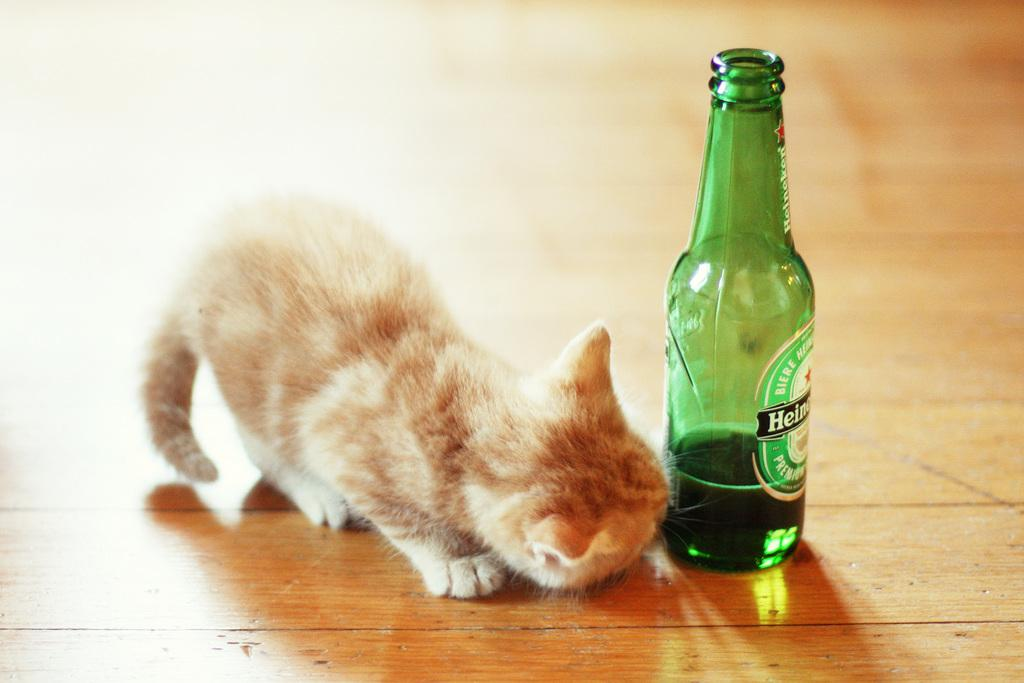What animal is present in the image? There is a cat in the image. What is the color of the cat? The cat is brown in color. What is the cat's focus in the image? The cat is watching a bottle. What is inside the bottle that the cat is watching? The bottle is filled with some liquid. What suggestion does the cat make to the viewer in the image? The image does not depict the cat making any suggestions to the viewer. 